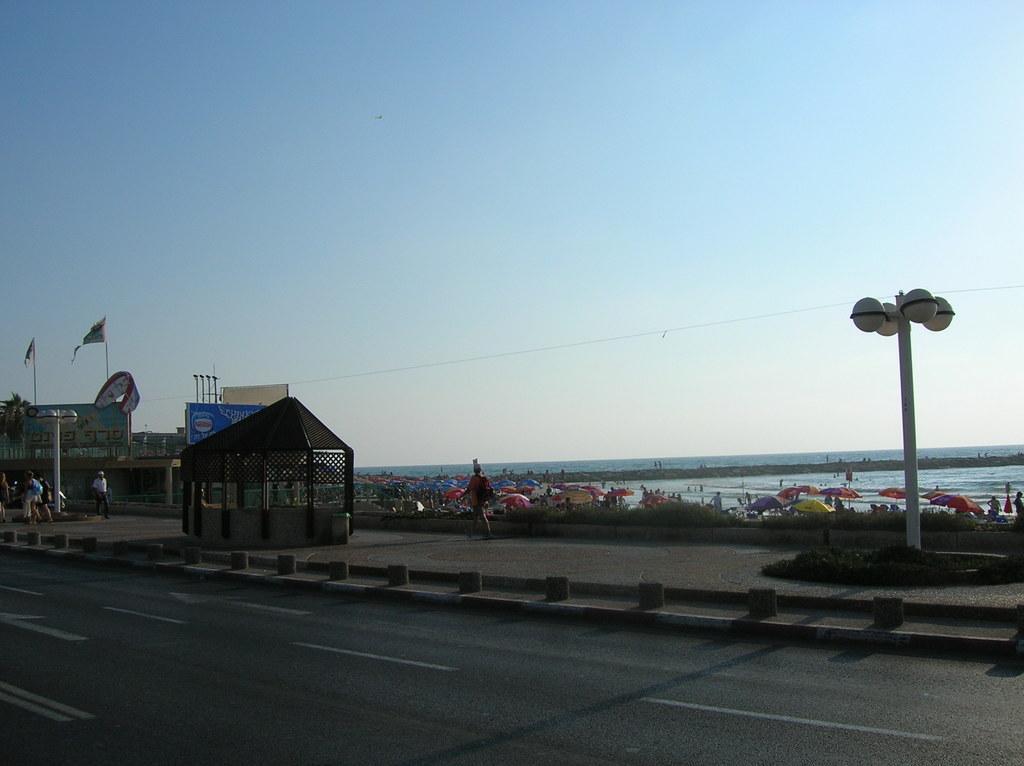Could you give a brief overview of what you see in this image? In this image we can see a roof with some poles. We can also see a large water body, a building, a parachute, the flag, umbrellas, street poles, a wire and the sky. 